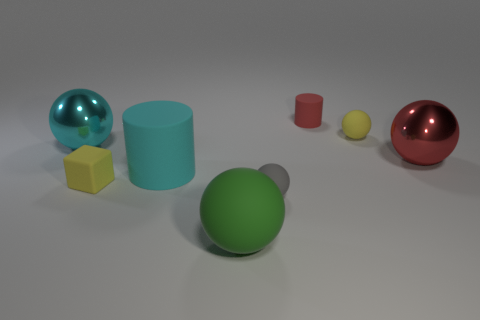Is there any other thing that has the same color as the big rubber ball?
Your answer should be compact. No. Does the shiny sphere that is to the right of the cyan metallic object have the same size as the matte cylinder to the left of the tiny cylinder?
Offer a very short reply. Yes. How many small things are either purple spheres or gray objects?
Offer a terse response. 1. How many things are metallic spheres to the right of the big cyan cylinder or red matte cylinders?
Provide a succinct answer. 2. Is the large matte sphere the same color as the rubber cube?
Your answer should be very brief. No. What number of other things are the same shape as the large red metal thing?
Offer a terse response. 4. How many purple things are either cylinders or tiny matte balls?
Offer a terse response. 0. There is a big ball that is made of the same material as the big red object; what is its color?
Your answer should be compact. Cyan. Are the cylinder behind the red metal object and the yellow thing to the right of the large green matte ball made of the same material?
Make the answer very short. Yes. The matte ball that is the same color as the tiny cube is what size?
Make the answer very short. Small. 